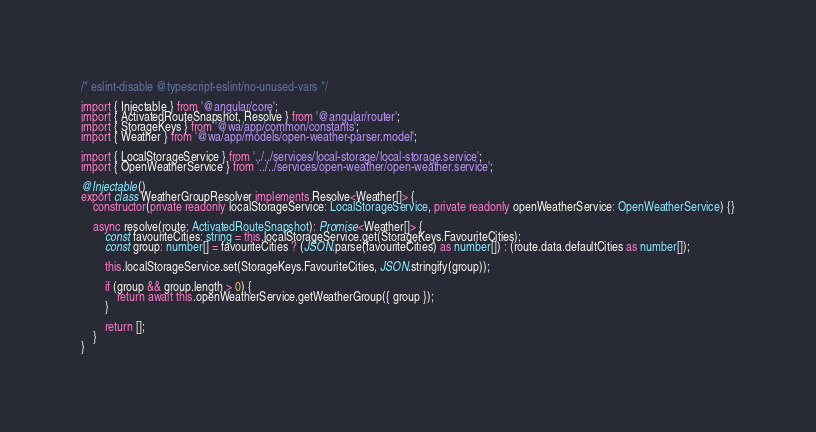Convert code to text. <code><loc_0><loc_0><loc_500><loc_500><_TypeScript_>/* eslint-disable @typescript-eslint/no-unused-vars */

import { Injectable } from '@angular/core';
import { ActivatedRouteSnapshot, Resolve } from '@angular/router';
import { StorageKeys } from '@wa/app/common/constants';
import { Weather } from '@wa/app/models/open-weather-parser.model';

import { LocalStorageService } from '../../services/local-storage/local-storage.service';
import { OpenWeatherService } from '../../services/open-weather/open-weather.service';

@Injectable()
export class WeatherGroupResolver implements Resolve<Weather[]> {
	constructor(private readonly localStorageService: LocalStorageService, private readonly openWeatherService: OpenWeatherService) {}

	async resolve(route: ActivatedRouteSnapshot): Promise<Weather[]> {
		const favouriteCities: string = this.localStorageService.get(StorageKeys.FavouriteCities);
		const group: number[] = favouriteCities ? (JSON.parse(favouriteCities) as number[]) : (route.data.defaultCities as number[]);

		this.localStorageService.set(StorageKeys.FavouriteCities, JSON.stringify(group));

		if (group && group.length > 0) {
			return await this.openWeatherService.getWeatherGroup({ group });
		}

		return [];
	}
}
</code> 